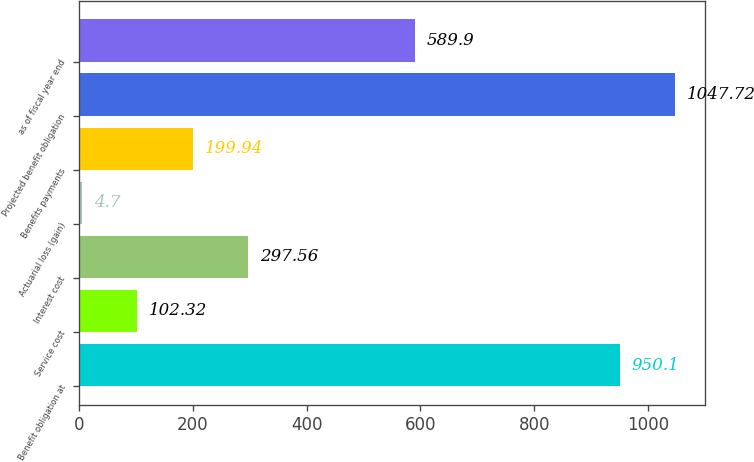Convert chart to OTSL. <chart><loc_0><loc_0><loc_500><loc_500><bar_chart><fcel>Benefit obligation at<fcel>Service cost<fcel>Interest cost<fcel>Actuarial loss (gain)<fcel>Benefits payments<fcel>Projected benefit obligation<fcel>as of fiscal year end<nl><fcel>950.1<fcel>102.32<fcel>297.56<fcel>4.7<fcel>199.94<fcel>1047.72<fcel>589.9<nl></chart> 